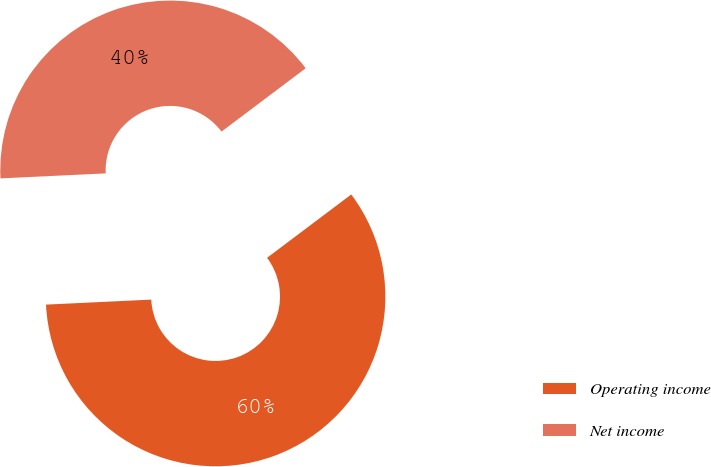<chart> <loc_0><loc_0><loc_500><loc_500><pie_chart><fcel>Operating income<fcel>Net income<nl><fcel>59.51%<fcel>40.49%<nl></chart> 